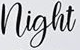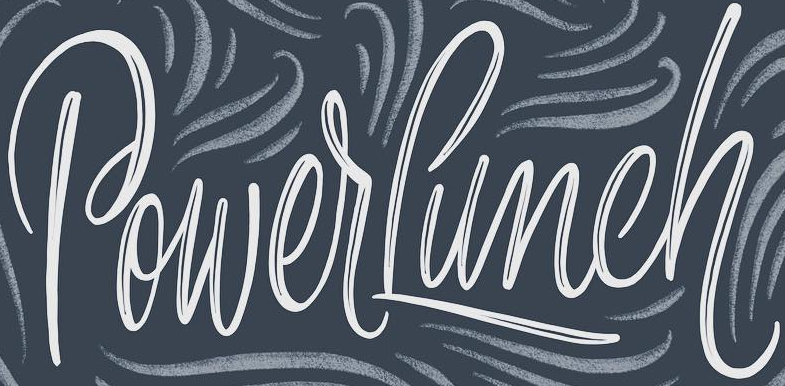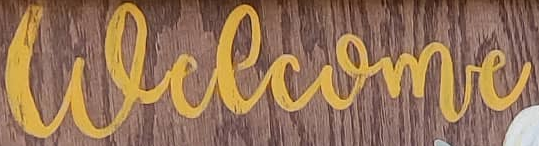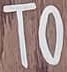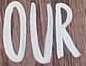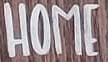What words can you see in these images in sequence, separated by a semicolon? night; PowerLunch; welcome; TO; OUR; HOME 